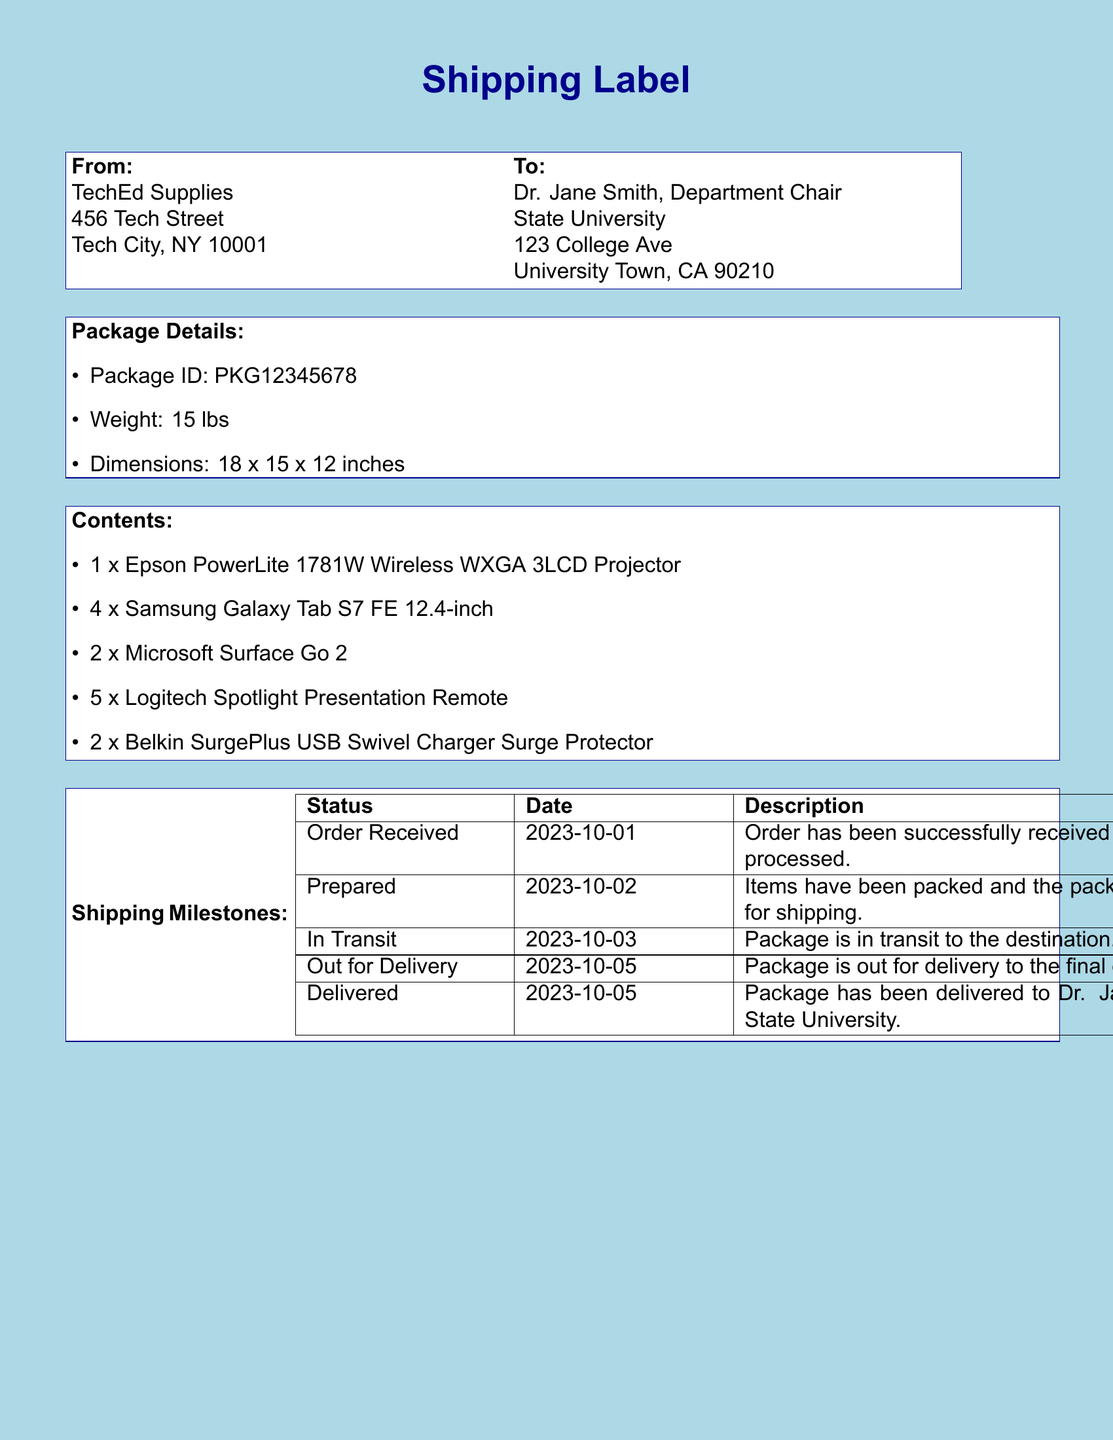What is the package ID? The package ID is specifically mentioned in the package details section of the document.
Answer: PKG12345678 Who is the sender of the package? The sender's name and address are provided in the 'From' section of the shipping label.
Answer: TechEd Supplies What items are included in the package? The contents section lists all the instructional technology tools included in the package.
Answer: 1 x Epson PowerLite 1781W Wireless WXGA 3LCD Projector, 4 x Samsung Galaxy Tab S7 FE 12.4-inch, 2 x Microsoft Surface Go 2, 5 x Logitech Spotlight Presentation Remote, 2 x Belkin SurgePlus USB Swivel Charger Surge Protector What is the total weight of the package? The weight of the package is provided in the package details section.
Answer: 15 lbs On what date was the package delivered? The delivery date is noted in the shipping milestones table.
Answer: 2023-10-05 What is the status of the package on October 3rd? The status on that date is listed under the shipping milestones section.
Answer: In Transit How many Samsung Galaxy Tab S7 FE tablets are included? The number of this specific item is noted in the contents section.
Answer: 4 Which item has the highest quantity in the package? By examining the contents, we can determine which item is included in the largest number.
Answer: 5 x Logitech Spotlight Presentation Remote 